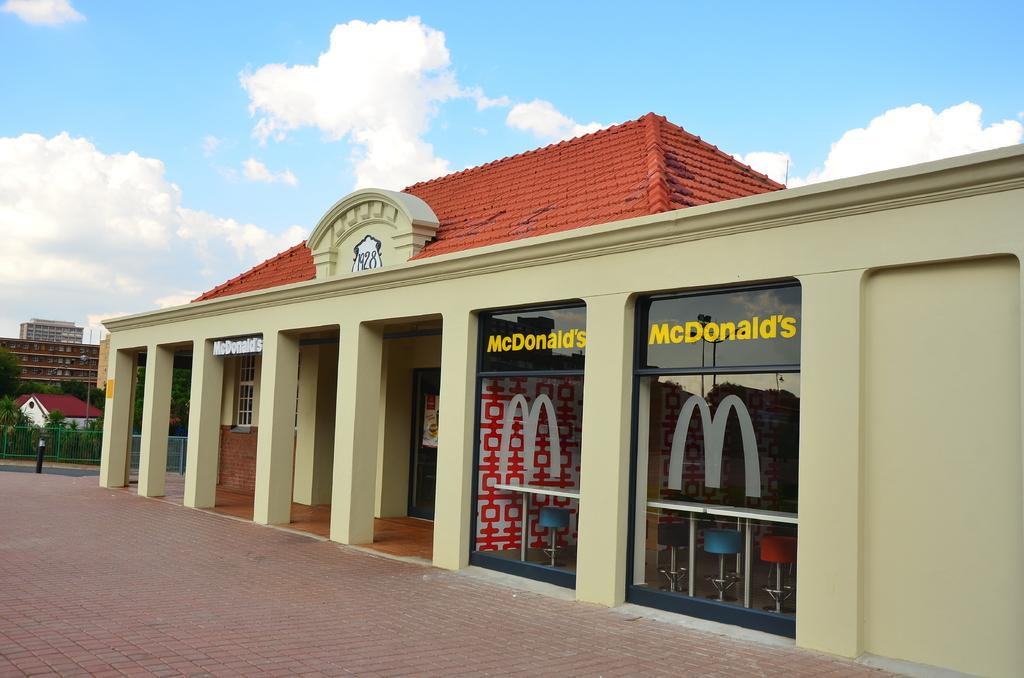<image>
Give a short and clear explanation of the subsequent image. a tan and red roof mcdonalds with two windwos. 